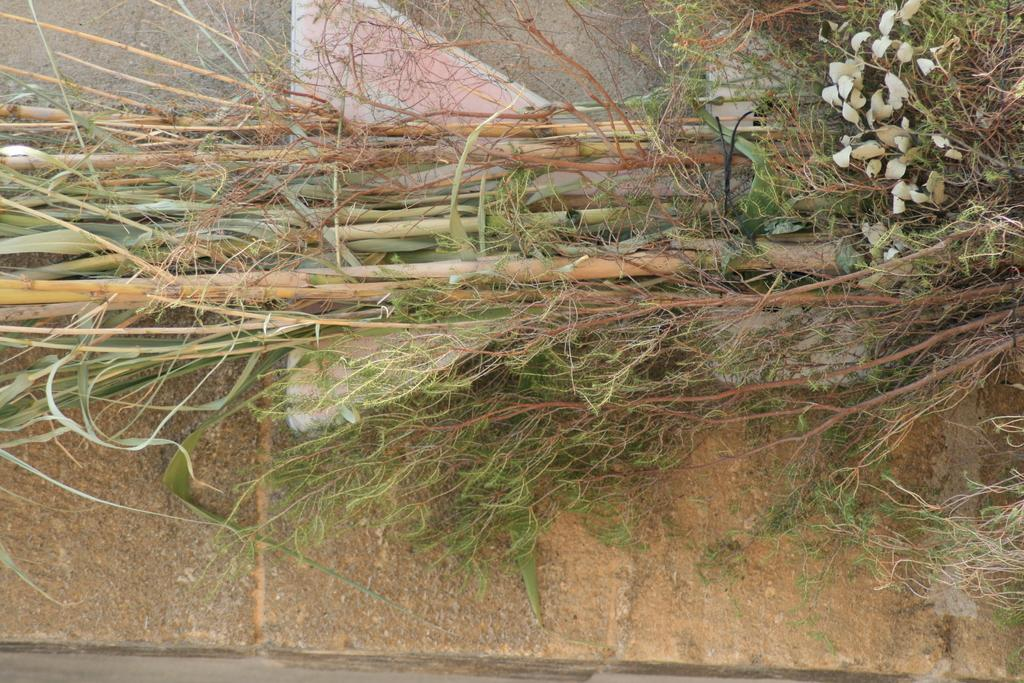What type of plant can be seen in the image? There are sugarcane in the image. What part of the sugarcane is visible in the image? There are leaves in the image. What can be seen in the background of the image? There is a wall in the background of the image. What direction is the sugarcane facing in the image? The direction the sugarcane is facing cannot be determined from the image, as plants do not have a specific direction they face. 